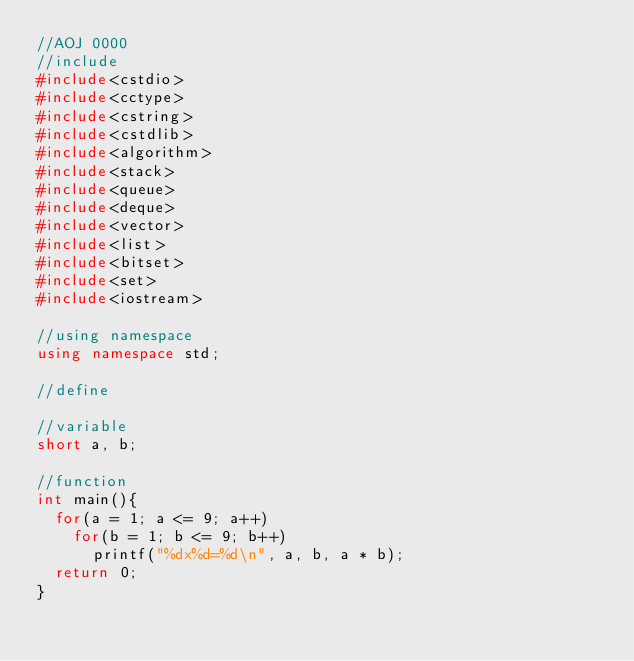Convert code to text. <code><loc_0><loc_0><loc_500><loc_500><_C++_>//AOJ 0000
//include
#include<cstdio>
#include<cctype>
#include<cstring>
#include<cstdlib>
#include<algorithm>
#include<stack>
#include<queue>
#include<deque>
#include<vector>
#include<list>
#include<bitset>
#include<set>
#include<iostream>

//using namespace
using namespace std;

//define

//variable
short a, b;

//function
int main(){
  for(a = 1; a <= 9; a++)
    for(b = 1; b <= 9; b++)
      printf("%dx%d=%d\n", a, b, a * b);
  return 0;
}</code> 